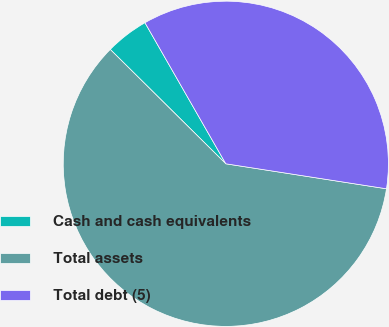Convert chart to OTSL. <chart><loc_0><loc_0><loc_500><loc_500><pie_chart><fcel>Cash and cash equivalents<fcel>Total assets<fcel>Total debt (5)<nl><fcel>4.3%<fcel>59.96%<fcel>35.74%<nl></chart> 